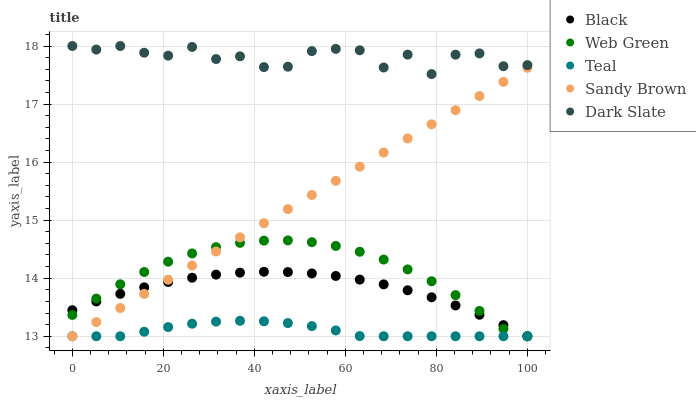Does Teal have the minimum area under the curve?
Answer yes or no. Yes. Does Dark Slate have the maximum area under the curve?
Answer yes or no. Yes. Does Black have the minimum area under the curve?
Answer yes or no. No. Does Black have the maximum area under the curve?
Answer yes or no. No. Is Sandy Brown the smoothest?
Answer yes or no. Yes. Is Dark Slate the roughest?
Answer yes or no. Yes. Is Black the smoothest?
Answer yes or no. No. Is Black the roughest?
Answer yes or no. No. Does Sandy Brown have the lowest value?
Answer yes or no. Yes. Does Dark Slate have the lowest value?
Answer yes or no. No. Does Dark Slate have the highest value?
Answer yes or no. Yes. Does Black have the highest value?
Answer yes or no. No. Is Sandy Brown less than Dark Slate?
Answer yes or no. Yes. Is Dark Slate greater than Teal?
Answer yes or no. Yes. Does Black intersect Teal?
Answer yes or no. Yes. Is Black less than Teal?
Answer yes or no. No. Is Black greater than Teal?
Answer yes or no. No. Does Sandy Brown intersect Dark Slate?
Answer yes or no. No. 